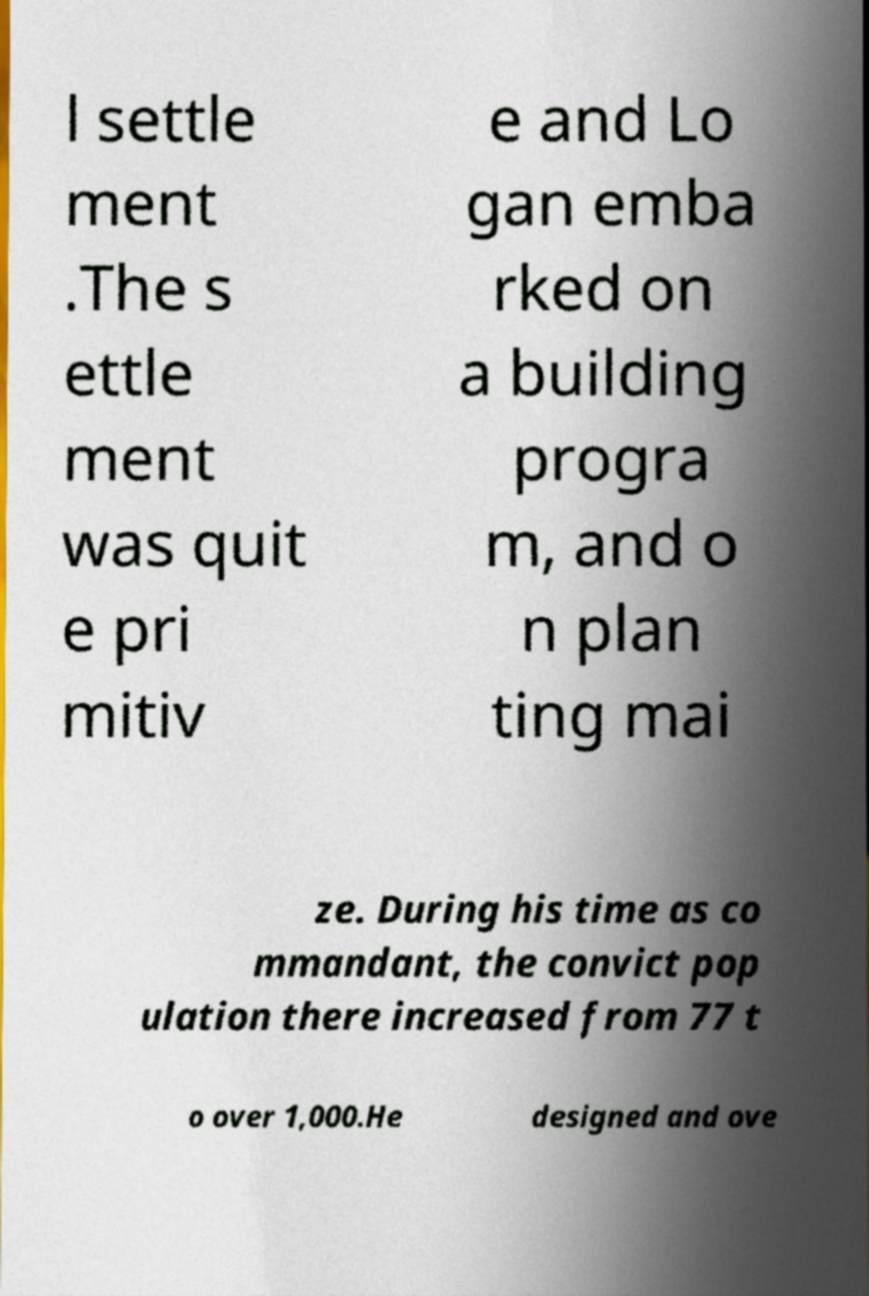For documentation purposes, I need the text within this image transcribed. Could you provide that? l settle ment .The s ettle ment was quit e pri mitiv e and Lo gan emba rked on a building progra m, and o n plan ting mai ze. During his time as co mmandant, the convict pop ulation there increased from 77 t o over 1,000.He designed and ove 